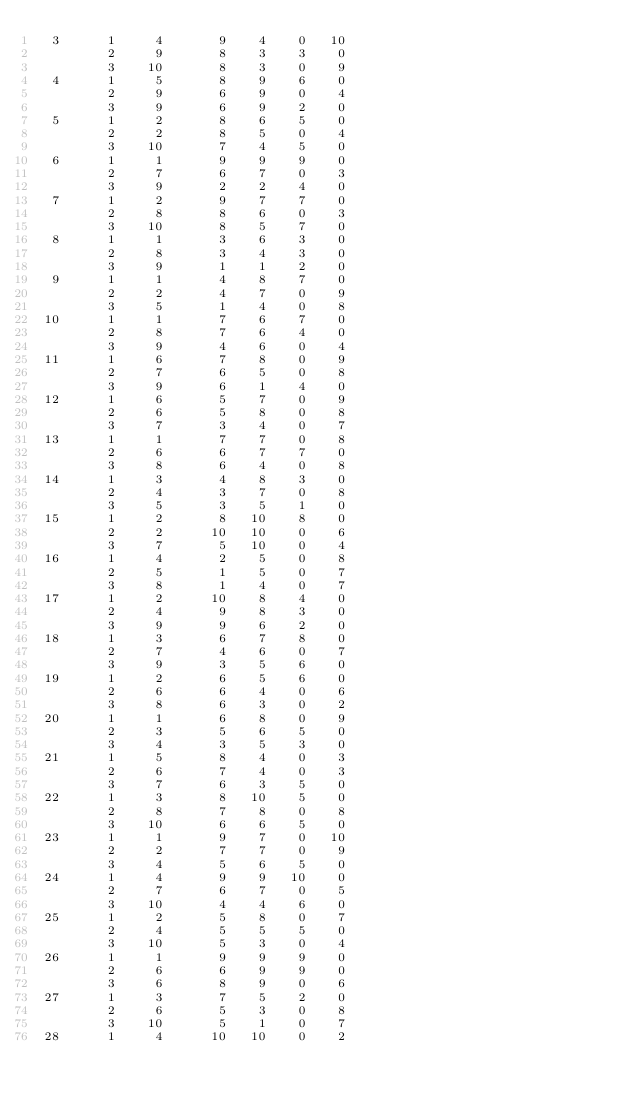Convert code to text. <code><loc_0><loc_0><loc_500><loc_500><_ObjectiveC_>  3      1     4       9    4    0   10
         2     9       8    3    3    0
         3    10       8    3    0    9
  4      1     5       8    9    6    0
         2     9       6    9    0    4
         3     9       6    9    2    0
  5      1     2       8    6    5    0
         2     2       8    5    0    4
         3    10       7    4    5    0
  6      1     1       9    9    9    0
         2     7       6    7    0    3
         3     9       2    2    4    0
  7      1     2       9    7    7    0
         2     8       8    6    0    3
         3    10       8    5    7    0
  8      1     1       3    6    3    0
         2     8       3    4    3    0
         3     9       1    1    2    0
  9      1     1       4    8    7    0
         2     2       4    7    0    9
         3     5       1    4    0    8
 10      1     1       7    6    7    0
         2     8       7    6    4    0
         3     9       4    6    0    4
 11      1     6       7    8    0    9
         2     7       6    5    0    8
         3     9       6    1    4    0
 12      1     6       5    7    0    9
         2     6       5    8    0    8
         3     7       3    4    0    7
 13      1     1       7    7    0    8
         2     6       6    7    7    0
         3     8       6    4    0    8
 14      1     3       4    8    3    0
         2     4       3    7    0    8
         3     5       3    5    1    0
 15      1     2       8   10    8    0
         2     2      10   10    0    6
         3     7       5   10    0    4
 16      1     4       2    5    0    8
         2     5       1    5    0    7
         3     8       1    4    0    7
 17      1     2      10    8    4    0
         2     4       9    8    3    0
         3     9       9    6    2    0
 18      1     3       6    7    8    0
         2     7       4    6    0    7
         3     9       3    5    6    0
 19      1     2       6    5    6    0
         2     6       6    4    0    6
         3     8       6    3    0    2
 20      1     1       6    8    0    9
         2     3       5    6    5    0
         3     4       3    5    3    0
 21      1     5       8    4    0    3
         2     6       7    4    0    3
         3     7       6    3    5    0
 22      1     3       8   10    5    0
         2     8       7    8    0    8
         3    10       6    6    5    0
 23      1     1       9    7    0   10
         2     2       7    7    0    9
         3     4       5    6    5    0
 24      1     4       9    9   10    0
         2     7       6    7    0    5
         3    10       4    4    6    0
 25      1     2       5    8    0    7
         2     4       5    5    5    0
         3    10       5    3    0    4
 26      1     1       9    9    9    0
         2     6       6    9    9    0
         3     6       8    9    0    6
 27      1     3       7    5    2    0
         2     6       5    3    0    8
         3    10       5    1    0    7
 28      1     4      10   10    0    2</code> 